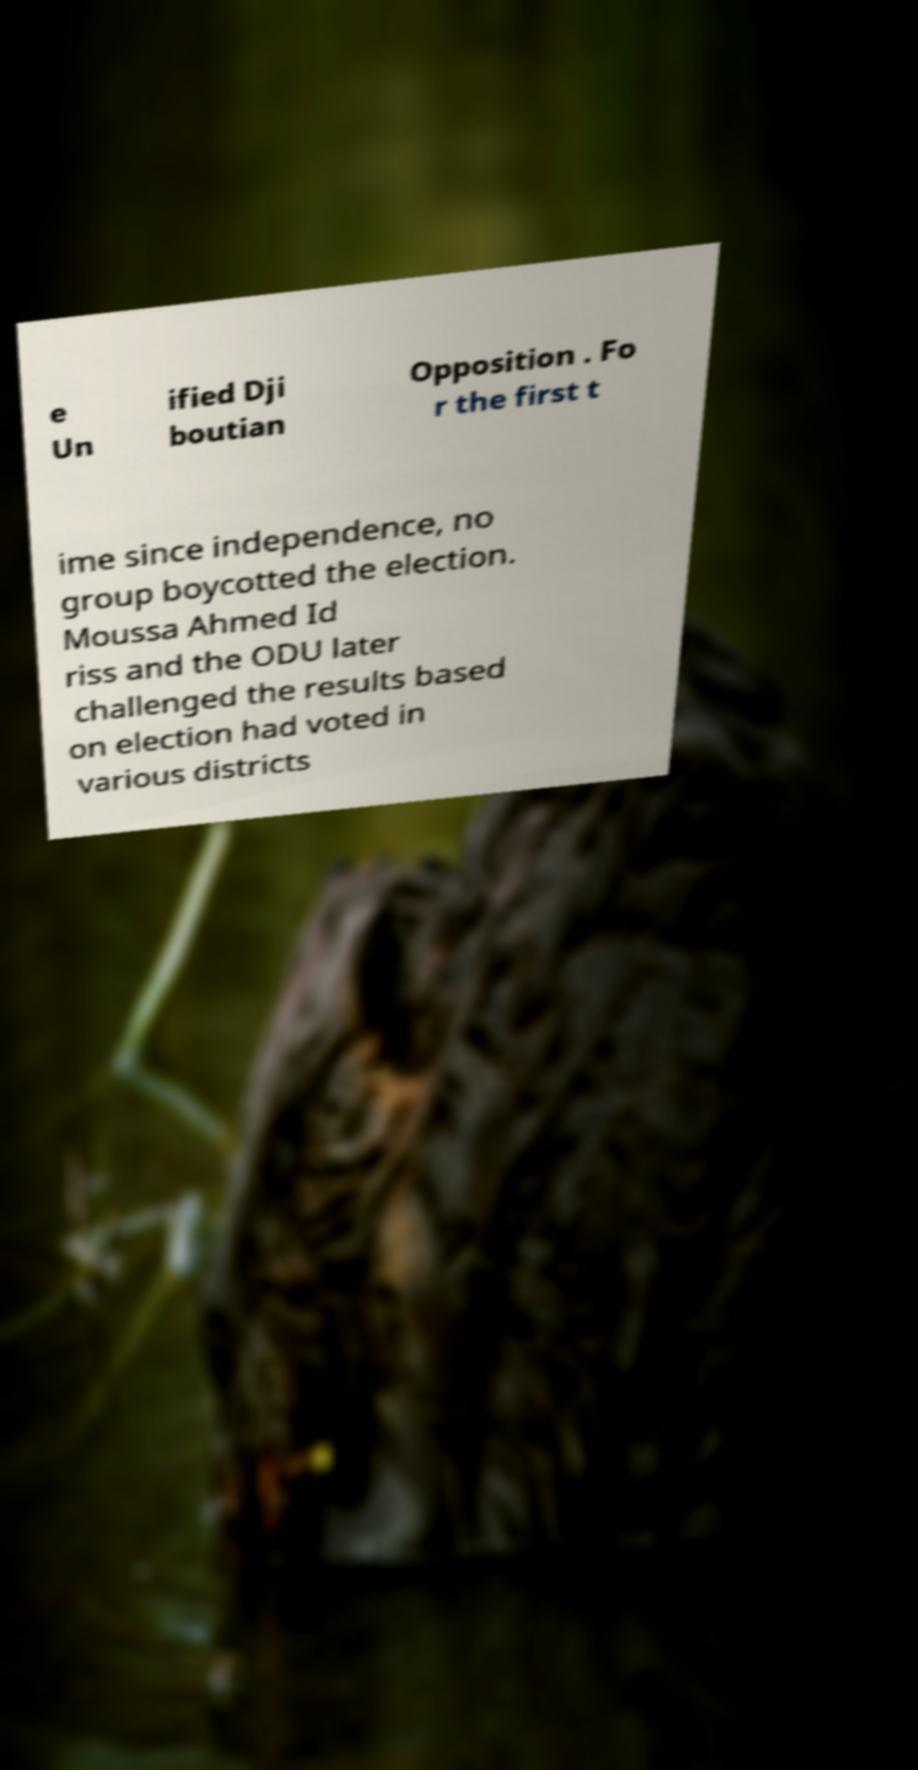For documentation purposes, I need the text within this image transcribed. Could you provide that? e Un ified Dji boutian Opposition . Fo r the first t ime since independence, no group boycotted the election. Moussa Ahmed Id riss and the ODU later challenged the results based on election had voted in various districts 